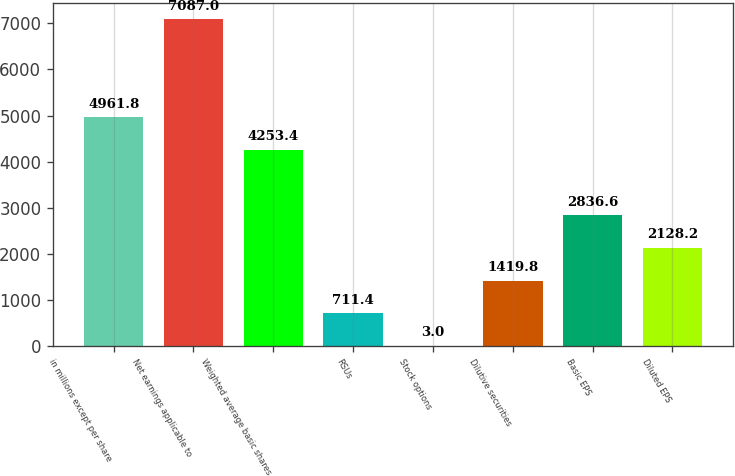Convert chart. <chart><loc_0><loc_0><loc_500><loc_500><bar_chart><fcel>in millions except per share<fcel>Net earnings applicable to<fcel>Weighted average basic shares<fcel>RSUs<fcel>Stock options<fcel>Dilutive securities<fcel>Basic EPS<fcel>Diluted EPS<nl><fcel>4961.8<fcel>7087<fcel>4253.4<fcel>711.4<fcel>3<fcel>1419.8<fcel>2836.6<fcel>2128.2<nl></chart> 